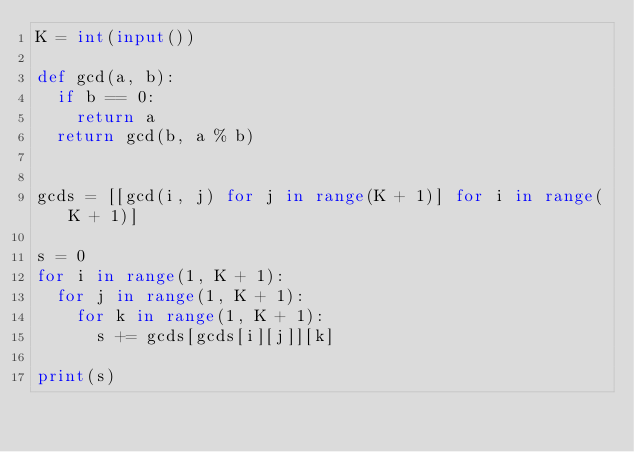<code> <loc_0><loc_0><loc_500><loc_500><_Python_>K = int(input())

def gcd(a, b):
  if b == 0:
    return a
  return gcd(b, a % b)


gcds = [[gcd(i, j) for j in range(K + 1)] for i in range(K + 1)]

s = 0
for i in range(1, K + 1):
  for j in range(1, K + 1):
    for k in range(1, K + 1):
      s += gcds[gcds[i][j]][k]

print(s)
</code> 